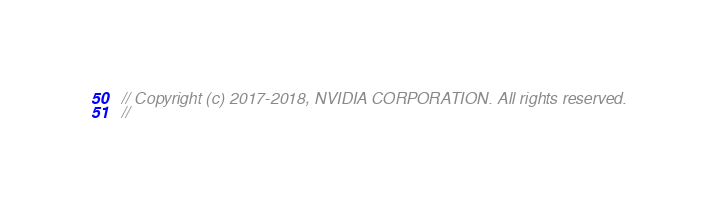<code> <loc_0><loc_0><loc_500><loc_500><_C_>// Copyright (c) 2017-2018, NVIDIA CORPORATION. All rights reserved.
//</code> 